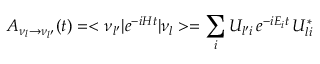<formula> <loc_0><loc_0><loc_500><loc_500>A _ { \nu _ { l } \to \nu _ { l ^ { \prime } } } ( t ) = < \nu _ { l ^ { \prime } } | e ^ { - i H t } | \nu _ { l } > = \sum _ { i } U _ { l ^ { \prime } i } \, e ^ { - i E _ { i } t } \, U _ { l i } ^ { * }</formula> 